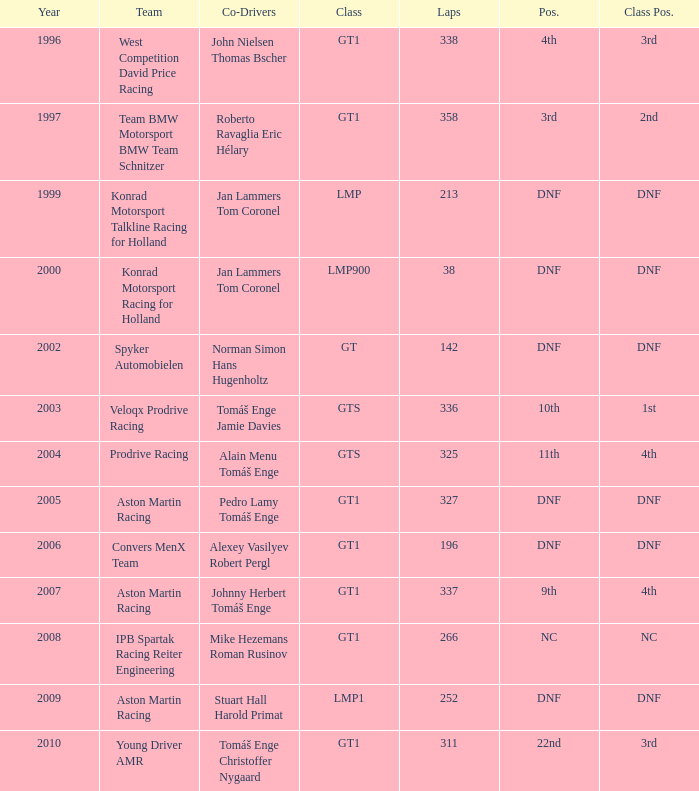What was the position in 1997? 3rd. 